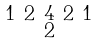<formula> <loc_0><loc_0><loc_500><loc_500>\begin{smallmatrix} 1 & 2 & 4 & 2 & 1 \\ & & 2 & & \end{smallmatrix}</formula> 